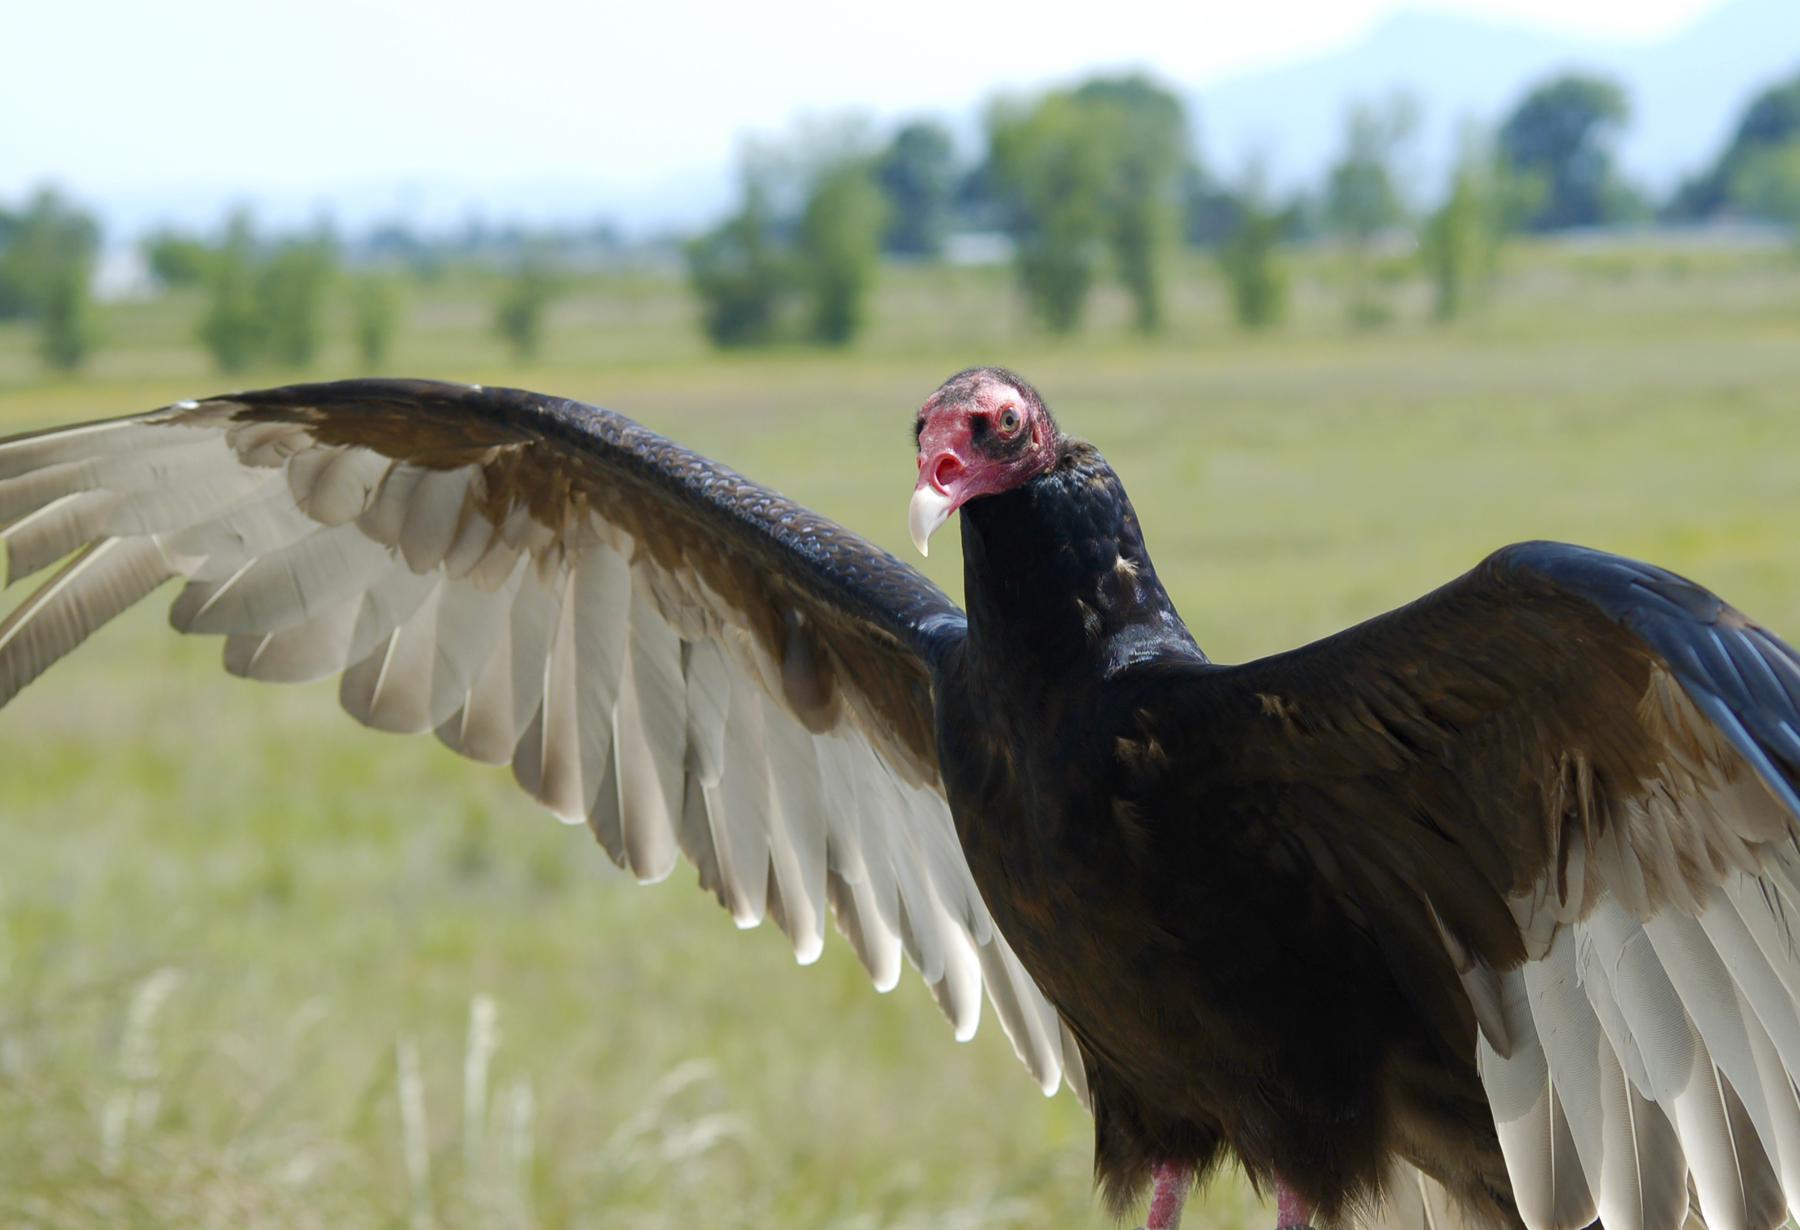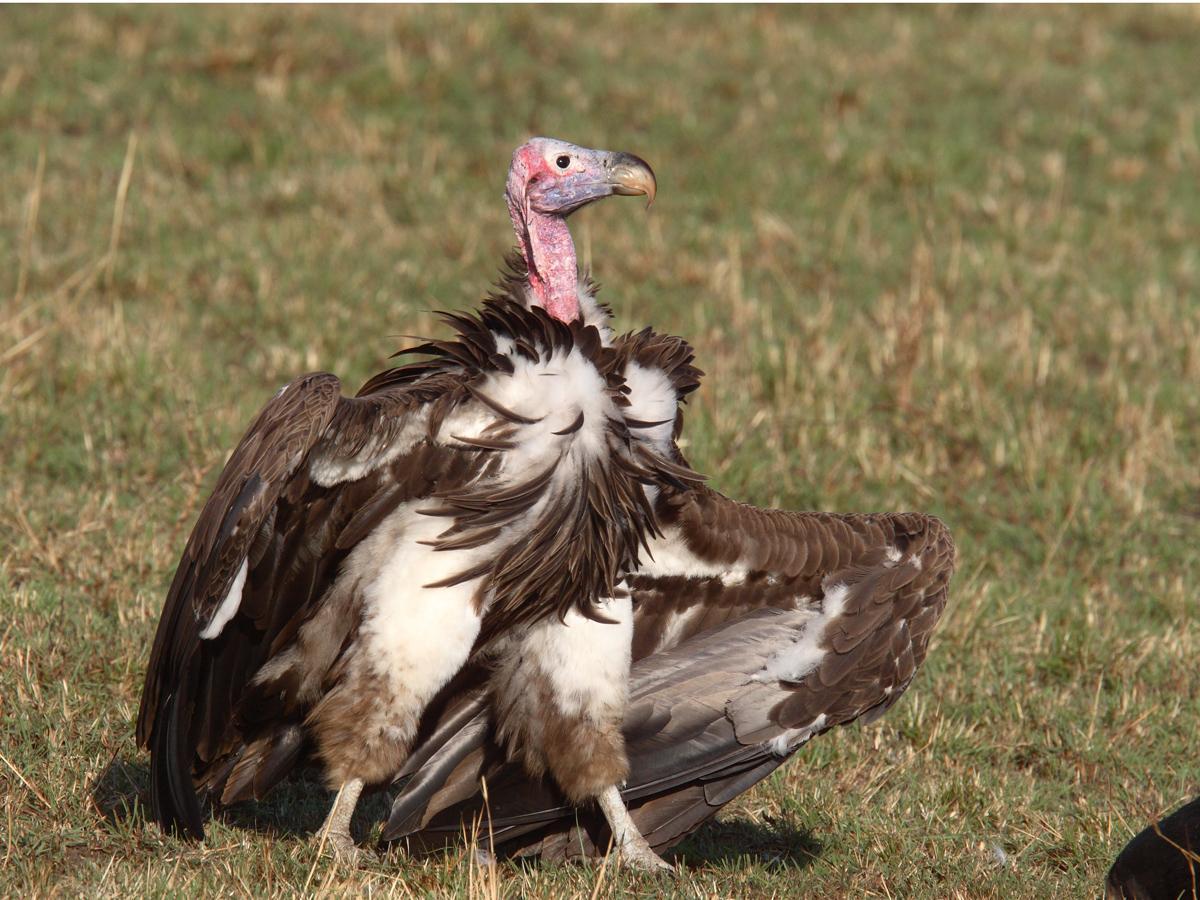The first image is the image on the left, the second image is the image on the right. Examine the images to the left and right. Is the description "In at least one image there is a closeup of a lone vultures face" accurate? Answer yes or no. No. The first image is the image on the left, the second image is the image on the right. Examine the images to the left and right. Is the description "The left image has two birds while the right only has one." accurate? Answer yes or no. No. 